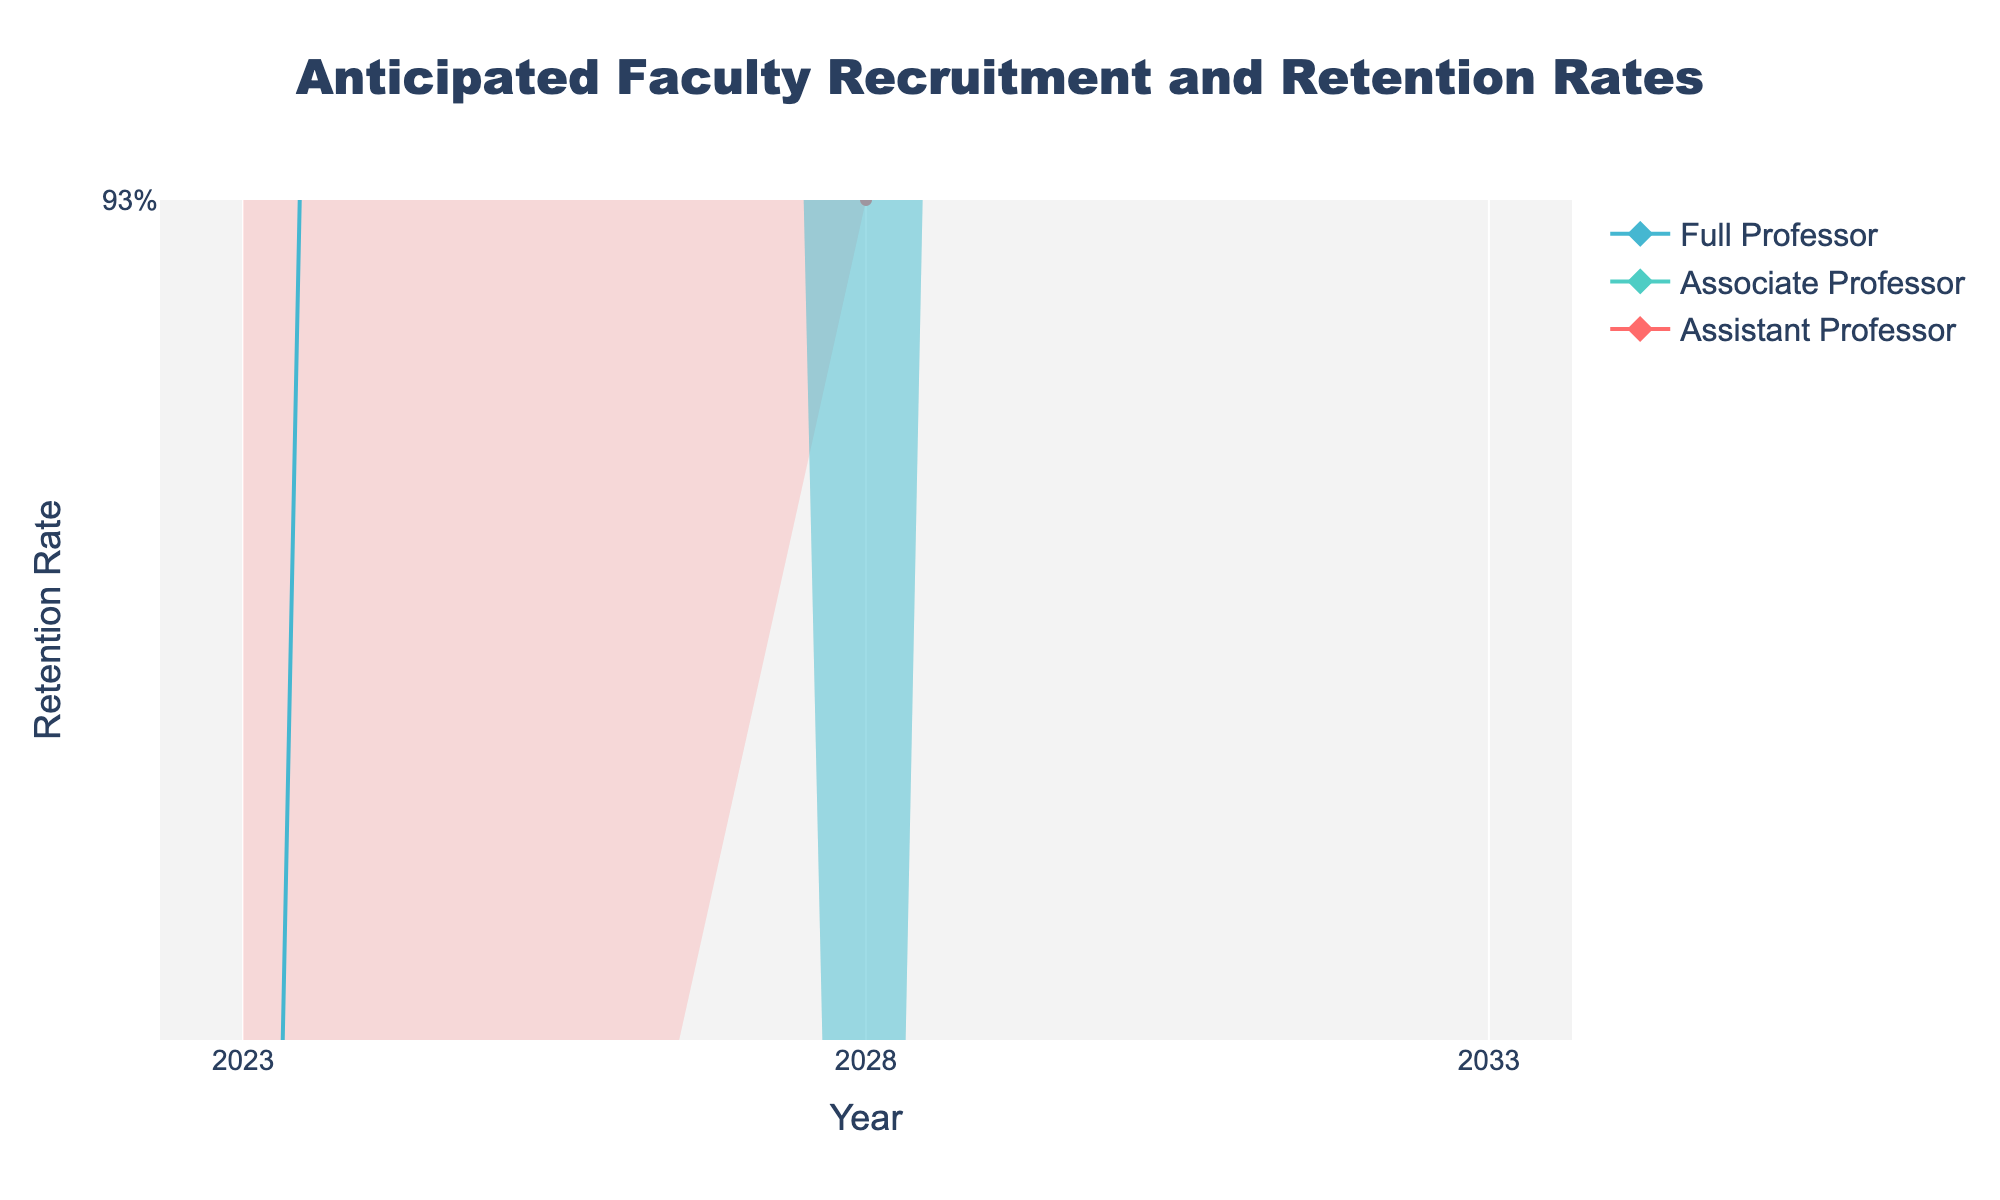What is the title of the figure? The title is located at the top center of the figure and states the main subject of the visualization.
Answer: Anticipated Faculty Recruitment and Retention Rates What do the x-axis and y-axis represent? The x-axis, located at the bottom of the figure, represents the years, while the y-axis on the left side represents the retention rates.
Answer: Years and Retention Rates How does the median retention rate of Assistant Professors change from 2023 to 2033? By observing the median values marked for Assistant Professors over the years, there is a noticeable downward trend in retention rates from 2023 (90%) to 2033 (85%).
Answer: Decreases from 90% to 85% Which academic rank shows the highest median retention rate in 2028? The median retention rates for 2028 can be compared across all ranks. Full Professors have the highest retention rate in that year.
Answer: Full Professor What is the lower quartile retention rate for Associate Professors in 2023? The lower quartile for each rank is indicated by the second shading layer from the bottom. For Associate Professors in 2023, it is 90%.
Answer: 90% By how much does the upper bound retention rate for Full Professors decrease from 2023 to 2033? The upper bound for Full Professors in 2023 is 98%, and in 2033 it is 96%. The decrease is calculated as 98% - 96%.
Answer: 2% Which academic rank experiences the most significant range in retention rates in 2033? The range is determined by the difference between the upper and lower bounds. Assistant Professors have the range from 92% to 75%, which is the largest spread.
Answer: Assistant Professor Do all academic ranks show an increase or decrease in median retention rates between 2023 and 2033? By observing the median line for each rank over time, all rank categories show a decrease in retention rates from 2023 to 2033.
Answer: Decrease How does the distribution of retention rates for Associate Professors change between 2023 and 2028? Comparing the spread of the interquartile ranges and medians between 2023 and 2028, there is a general downward shift in retention rates. The lower and upper quartiles shift from 90% - 94% in 2023 to 88% - 92% in 2028.
Answer: Shifts downward from 90%-94% to 88%-92% Which academic rank shows the least variation in retention rates over the years? The variation can be evaluated by comparing the widths of the shaded areas between years for each rank. Full Professors have the smallest spread between bounds over the years.
Answer: Full Professor 